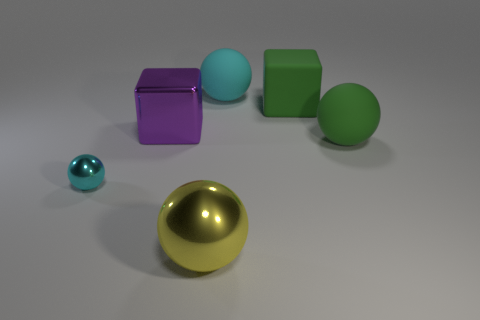Is the number of big yellow things greater than the number of blue things?
Your response must be concise. Yes. There is a sphere that is both behind the large yellow sphere and to the left of the big cyan sphere; how big is it?
Give a very brief answer. Small. The large cube that is in front of the big green matte object behind the large rubber thing in front of the purple cube is made of what material?
Offer a terse response. Metal. Do the tiny metal thing in front of the big green matte ball and the big ball that is behind the purple metallic thing have the same color?
Provide a short and direct response. Yes. The big shiny object behind the cyan metallic sphere that is on the left side of the metallic object that is behind the small sphere is what shape?
Provide a short and direct response. Cube. What shape is the object that is right of the cyan matte object and behind the purple object?
Provide a short and direct response. Cube. How many large green blocks are on the right side of the big ball that is behind the large shiny object that is to the left of the yellow metal thing?
Offer a terse response. 1. What size is the green matte object that is the same shape as the yellow thing?
Offer a very short reply. Large. Is there anything else that is the same size as the cyan metallic object?
Offer a very short reply. No. Is the large green thing that is behind the purple shiny object made of the same material as the large cyan sphere?
Keep it short and to the point. Yes. 